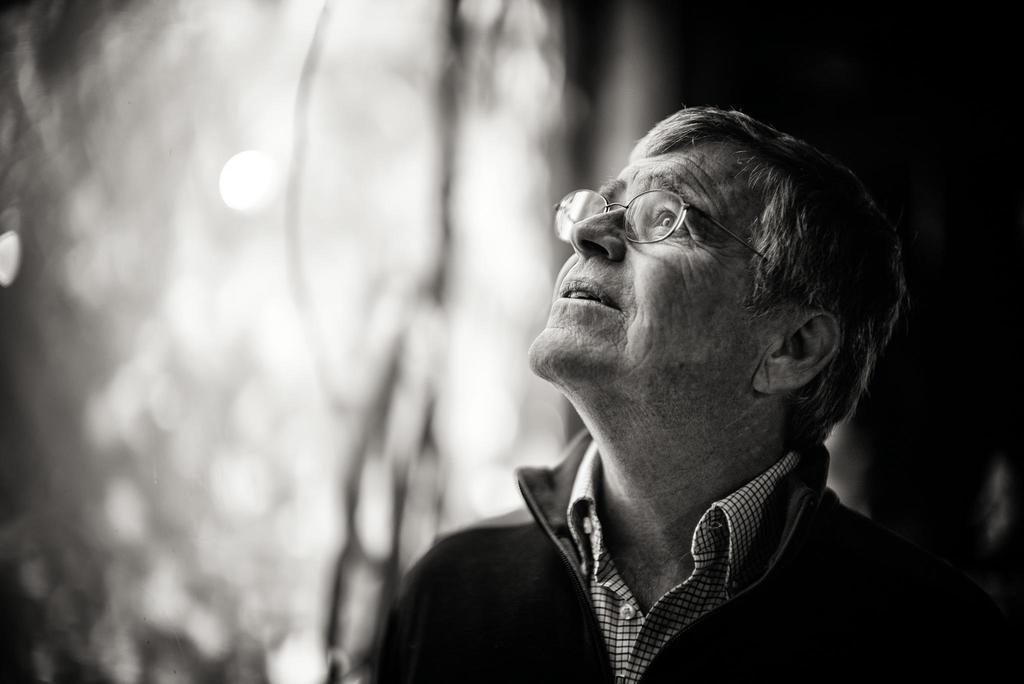Please provide a concise description of this image. There is a man looking at upwards and wore spectacle. In the background it is blur. 